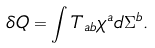<formula> <loc_0><loc_0><loc_500><loc_500>\delta Q = \int T _ { a b } \chi ^ { a } d \Sigma ^ { b } .</formula> 